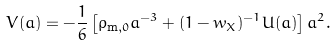<formula> <loc_0><loc_0><loc_500><loc_500>V ( a ) = - \frac { 1 } { 6 } \left [ \rho _ { \text {m} , 0 } a ^ { - 3 } + ( 1 - w _ { X } ) ^ { - 1 } U ( a ) \right ] a ^ { 2 } .</formula> 